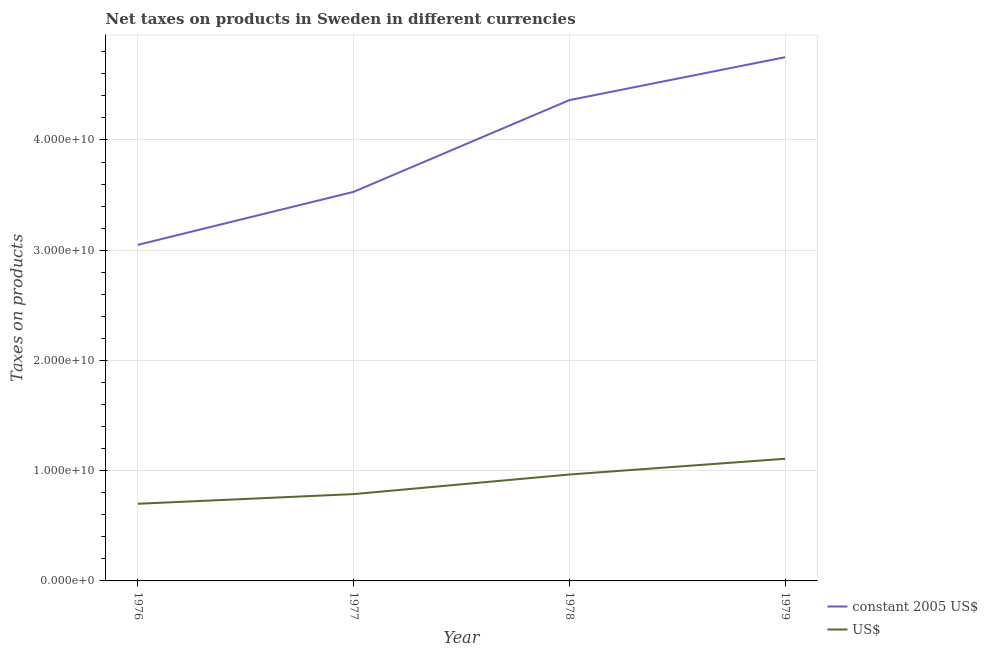How many different coloured lines are there?
Keep it short and to the point. 2. What is the net taxes in us$ in 1978?
Ensure brevity in your answer.  9.65e+09. Across all years, what is the maximum net taxes in constant 2005 us$?
Give a very brief answer. 4.75e+1. Across all years, what is the minimum net taxes in us$?
Keep it short and to the point. 7.00e+09. In which year was the net taxes in us$ maximum?
Make the answer very short. 1979. In which year was the net taxes in us$ minimum?
Ensure brevity in your answer.  1976. What is the total net taxes in us$ in the graph?
Give a very brief answer. 3.56e+1. What is the difference between the net taxes in constant 2005 us$ in 1976 and that in 1979?
Offer a terse response. -1.70e+1. What is the difference between the net taxes in us$ in 1978 and the net taxes in constant 2005 us$ in 1976?
Make the answer very short. -2.08e+1. What is the average net taxes in constant 2005 us$ per year?
Your response must be concise. 3.92e+1. In the year 1978, what is the difference between the net taxes in us$ and net taxes in constant 2005 us$?
Ensure brevity in your answer.  -3.40e+1. In how many years, is the net taxes in constant 2005 us$ greater than 44000000000 units?
Make the answer very short. 1. What is the ratio of the net taxes in constant 2005 us$ in 1977 to that in 1979?
Your answer should be very brief. 0.74. Is the net taxes in constant 2005 us$ in 1976 less than that in 1978?
Offer a very short reply. Yes. Is the difference between the net taxes in constant 2005 us$ in 1976 and 1979 greater than the difference between the net taxes in us$ in 1976 and 1979?
Give a very brief answer. No. What is the difference between the highest and the second highest net taxes in us$?
Provide a short and direct response. 1.43e+09. What is the difference between the highest and the lowest net taxes in constant 2005 us$?
Keep it short and to the point. 1.70e+1. In how many years, is the net taxes in constant 2005 us$ greater than the average net taxes in constant 2005 us$ taken over all years?
Ensure brevity in your answer.  2. Is the sum of the net taxes in constant 2005 us$ in 1977 and 1978 greater than the maximum net taxes in us$ across all years?
Your response must be concise. Yes. Does the net taxes in constant 2005 us$ monotonically increase over the years?
Provide a succinct answer. Yes. Is the net taxes in constant 2005 us$ strictly greater than the net taxes in us$ over the years?
Offer a terse response. Yes. Is the net taxes in us$ strictly less than the net taxes in constant 2005 us$ over the years?
Offer a very short reply. Yes. How many lines are there?
Your response must be concise. 2. How many legend labels are there?
Offer a very short reply. 2. How are the legend labels stacked?
Make the answer very short. Vertical. What is the title of the graph?
Your response must be concise. Net taxes on products in Sweden in different currencies. What is the label or title of the X-axis?
Provide a succinct answer. Year. What is the label or title of the Y-axis?
Provide a succinct answer. Taxes on products. What is the Taxes on products of constant 2005 US$ in 1976?
Provide a succinct answer. 3.05e+1. What is the Taxes on products of US$ in 1976?
Offer a very short reply. 7.00e+09. What is the Taxes on products in constant 2005 US$ in 1977?
Make the answer very short. 3.53e+1. What is the Taxes on products in US$ in 1977?
Give a very brief answer. 7.88e+09. What is the Taxes on products of constant 2005 US$ in 1978?
Make the answer very short. 4.36e+1. What is the Taxes on products in US$ in 1978?
Give a very brief answer. 9.65e+09. What is the Taxes on products of constant 2005 US$ in 1979?
Keep it short and to the point. 4.75e+1. What is the Taxes on products in US$ in 1979?
Offer a terse response. 1.11e+1. Across all years, what is the maximum Taxes on products of constant 2005 US$?
Offer a very short reply. 4.75e+1. Across all years, what is the maximum Taxes on products in US$?
Make the answer very short. 1.11e+1. Across all years, what is the minimum Taxes on products of constant 2005 US$?
Ensure brevity in your answer.  3.05e+1. Across all years, what is the minimum Taxes on products in US$?
Make the answer very short. 7.00e+09. What is the total Taxes on products of constant 2005 US$ in the graph?
Offer a very short reply. 1.57e+11. What is the total Taxes on products in US$ in the graph?
Your response must be concise. 3.56e+1. What is the difference between the Taxes on products in constant 2005 US$ in 1976 and that in 1977?
Ensure brevity in your answer.  -4.81e+09. What is the difference between the Taxes on products of US$ in 1976 and that in 1977?
Your answer should be very brief. -8.76e+08. What is the difference between the Taxes on products of constant 2005 US$ in 1976 and that in 1978?
Offer a very short reply. -1.31e+1. What is the difference between the Taxes on products of US$ in 1976 and that in 1978?
Offer a very short reply. -2.65e+09. What is the difference between the Taxes on products of constant 2005 US$ in 1976 and that in 1979?
Your response must be concise. -1.70e+1. What is the difference between the Taxes on products in US$ in 1976 and that in 1979?
Offer a very short reply. -4.08e+09. What is the difference between the Taxes on products of constant 2005 US$ in 1977 and that in 1978?
Provide a short and direct response. -8.32e+09. What is the difference between the Taxes on products in US$ in 1977 and that in 1978?
Give a very brief answer. -1.78e+09. What is the difference between the Taxes on products in constant 2005 US$ in 1977 and that in 1979?
Give a very brief answer. -1.22e+1. What is the difference between the Taxes on products in US$ in 1977 and that in 1979?
Ensure brevity in your answer.  -3.21e+09. What is the difference between the Taxes on products in constant 2005 US$ in 1978 and that in 1979?
Provide a short and direct response. -3.89e+09. What is the difference between the Taxes on products in US$ in 1978 and that in 1979?
Your answer should be compact. -1.43e+09. What is the difference between the Taxes on products in constant 2005 US$ in 1976 and the Taxes on products in US$ in 1977?
Offer a very short reply. 2.26e+1. What is the difference between the Taxes on products of constant 2005 US$ in 1976 and the Taxes on products of US$ in 1978?
Offer a terse response. 2.08e+1. What is the difference between the Taxes on products of constant 2005 US$ in 1976 and the Taxes on products of US$ in 1979?
Offer a terse response. 1.94e+1. What is the difference between the Taxes on products in constant 2005 US$ in 1977 and the Taxes on products in US$ in 1978?
Offer a very short reply. 2.56e+1. What is the difference between the Taxes on products of constant 2005 US$ in 1977 and the Taxes on products of US$ in 1979?
Your answer should be very brief. 2.42e+1. What is the difference between the Taxes on products in constant 2005 US$ in 1978 and the Taxes on products in US$ in 1979?
Provide a short and direct response. 3.25e+1. What is the average Taxes on products in constant 2005 US$ per year?
Give a very brief answer. 3.92e+1. What is the average Taxes on products of US$ per year?
Make the answer very short. 8.90e+09. In the year 1976, what is the difference between the Taxes on products in constant 2005 US$ and Taxes on products in US$?
Offer a terse response. 2.35e+1. In the year 1977, what is the difference between the Taxes on products in constant 2005 US$ and Taxes on products in US$?
Offer a very short reply. 2.74e+1. In the year 1978, what is the difference between the Taxes on products of constant 2005 US$ and Taxes on products of US$?
Offer a very short reply. 3.40e+1. In the year 1979, what is the difference between the Taxes on products of constant 2005 US$ and Taxes on products of US$?
Offer a terse response. 3.64e+1. What is the ratio of the Taxes on products of constant 2005 US$ in 1976 to that in 1977?
Make the answer very short. 0.86. What is the ratio of the Taxes on products of US$ in 1976 to that in 1977?
Ensure brevity in your answer.  0.89. What is the ratio of the Taxes on products in constant 2005 US$ in 1976 to that in 1978?
Your answer should be very brief. 0.7. What is the ratio of the Taxes on products of US$ in 1976 to that in 1978?
Make the answer very short. 0.73. What is the ratio of the Taxes on products of constant 2005 US$ in 1976 to that in 1979?
Give a very brief answer. 0.64. What is the ratio of the Taxes on products in US$ in 1976 to that in 1979?
Provide a short and direct response. 0.63. What is the ratio of the Taxes on products in constant 2005 US$ in 1977 to that in 1978?
Your answer should be compact. 0.81. What is the ratio of the Taxes on products in US$ in 1977 to that in 1978?
Offer a very short reply. 0.82. What is the ratio of the Taxes on products of constant 2005 US$ in 1977 to that in 1979?
Keep it short and to the point. 0.74. What is the ratio of the Taxes on products in US$ in 1977 to that in 1979?
Give a very brief answer. 0.71. What is the ratio of the Taxes on products of constant 2005 US$ in 1978 to that in 1979?
Make the answer very short. 0.92. What is the ratio of the Taxes on products in US$ in 1978 to that in 1979?
Ensure brevity in your answer.  0.87. What is the difference between the highest and the second highest Taxes on products of constant 2005 US$?
Ensure brevity in your answer.  3.89e+09. What is the difference between the highest and the second highest Taxes on products of US$?
Give a very brief answer. 1.43e+09. What is the difference between the highest and the lowest Taxes on products in constant 2005 US$?
Make the answer very short. 1.70e+1. What is the difference between the highest and the lowest Taxes on products in US$?
Ensure brevity in your answer.  4.08e+09. 